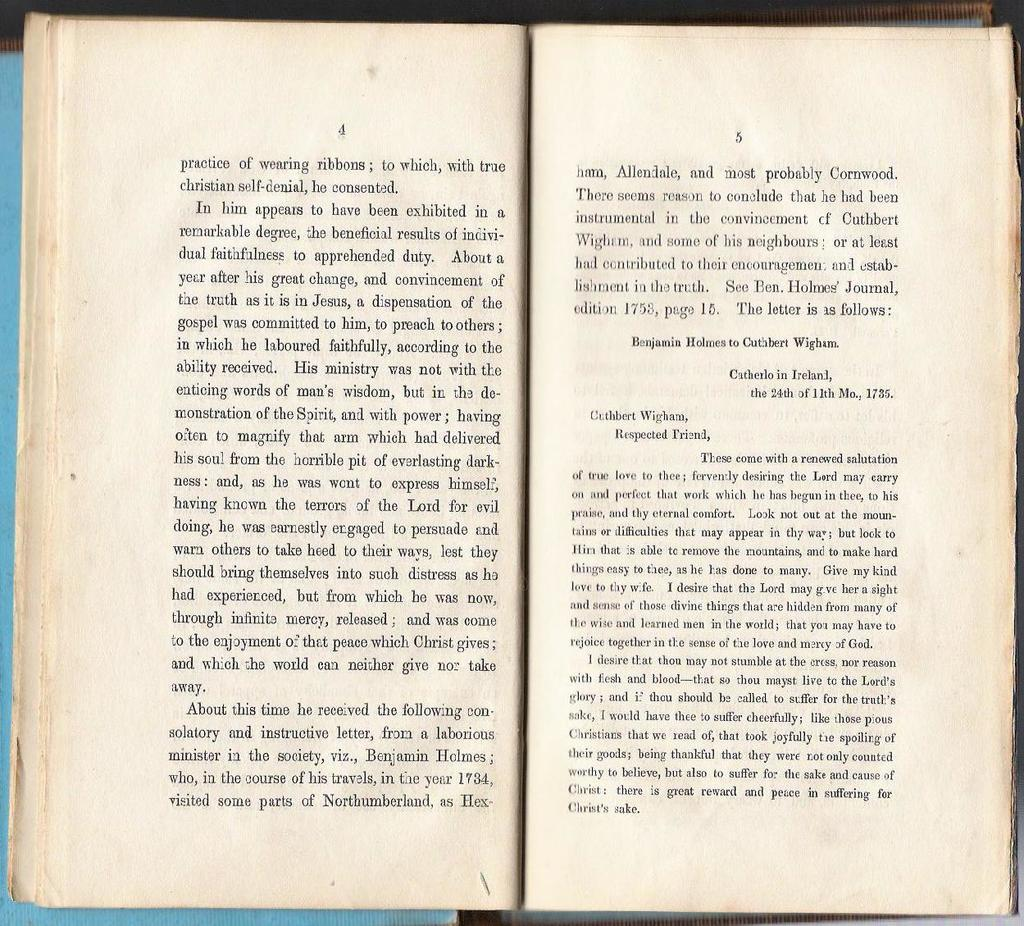What is the main object in the image? There is a book in the image. What else can be seen related to written material in the image? There are papers with writing in the image. Can you describe the object behind the book? Unfortunately, the provided facts do not give enough information to describe the object behind the book. Where is the monkey's nest located in the image? There is no monkey or nest present in the image. 